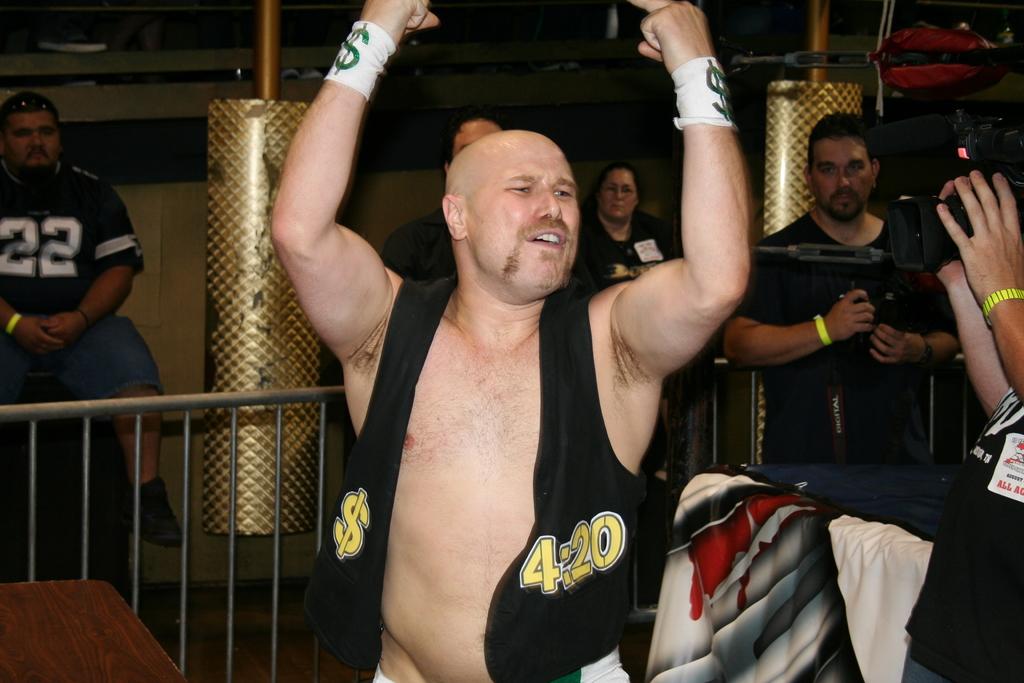Is he an english chef?
Your response must be concise. Unanswerable. 